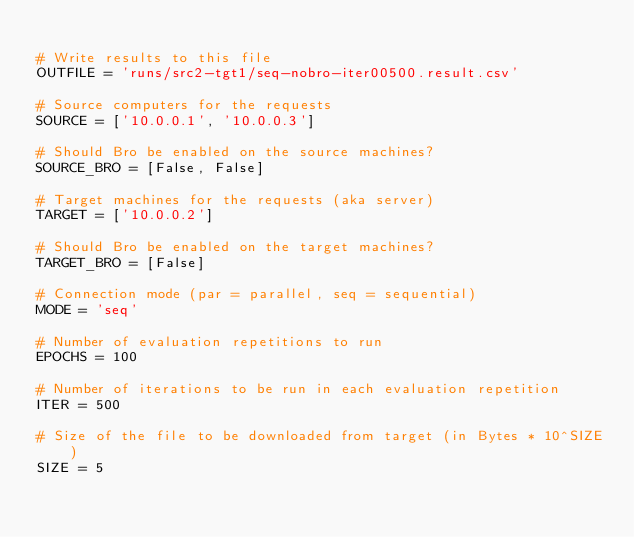Convert code to text. <code><loc_0><loc_0><loc_500><loc_500><_Python_>
# Write results to this file
OUTFILE = 'runs/src2-tgt1/seq-nobro-iter00500.result.csv'

# Source computers for the requests
SOURCE = ['10.0.0.1', '10.0.0.3']

# Should Bro be enabled on the source machines?
SOURCE_BRO = [False, False]

# Target machines for the requests (aka server)
TARGET = ['10.0.0.2']

# Should Bro be enabled on the target machines?
TARGET_BRO = [False]

# Connection mode (par = parallel, seq = sequential)
MODE = 'seq'

# Number of evaluation repetitions to run
EPOCHS = 100

# Number of iterations to be run in each evaluation repetition
ITER = 500

# Size of the file to be downloaded from target (in Bytes * 10^SIZE)
SIZE = 5

</code> 